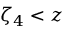Convert formula to latex. <formula><loc_0><loc_0><loc_500><loc_500>\zeta _ { 4 } < z</formula> 